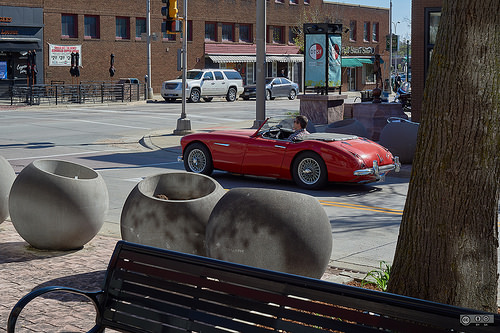<image>
Can you confirm if the car is behind the tree? Yes. From this viewpoint, the car is positioned behind the tree, with the tree partially or fully occluding the car. Where is the chair in relation to the tree? Is it behind the tree? No. The chair is not behind the tree. From this viewpoint, the chair appears to be positioned elsewhere in the scene. Is there a man on the pole? No. The man is not positioned on the pole. They may be near each other, but the man is not supported by or resting on top of the pole. Is the bench in front of the car? Yes. The bench is positioned in front of the car, appearing closer to the camera viewpoint. 